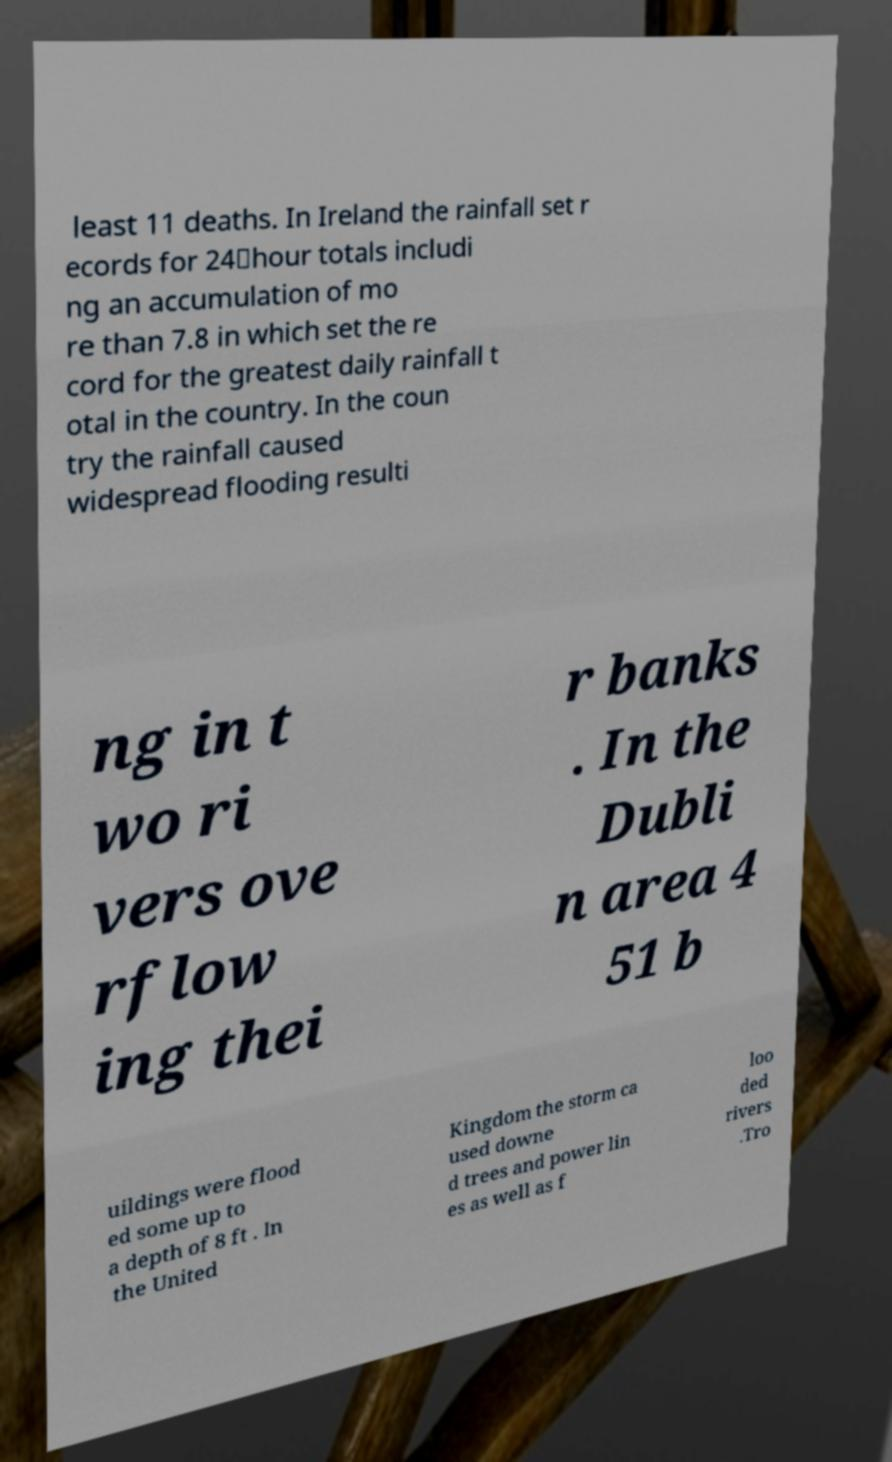I need the written content from this picture converted into text. Can you do that? least 11 deaths. In Ireland the rainfall set r ecords for 24‑hour totals includi ng an accumulation of mo re than 7.8 in which set the re cord for the greatest daily rainfall t otal in the country. In the coun try the rainfall caused widespread flooding resulti ng in t wo ri vers ove rflow ing thei r banks . In the Dubli n area 4 51 b uildings were flood ed some up to a depth of 8 ft . In the United Kingdom the storm ca used downe d trees and power lin es as well as f loo ded rivers .Tro 